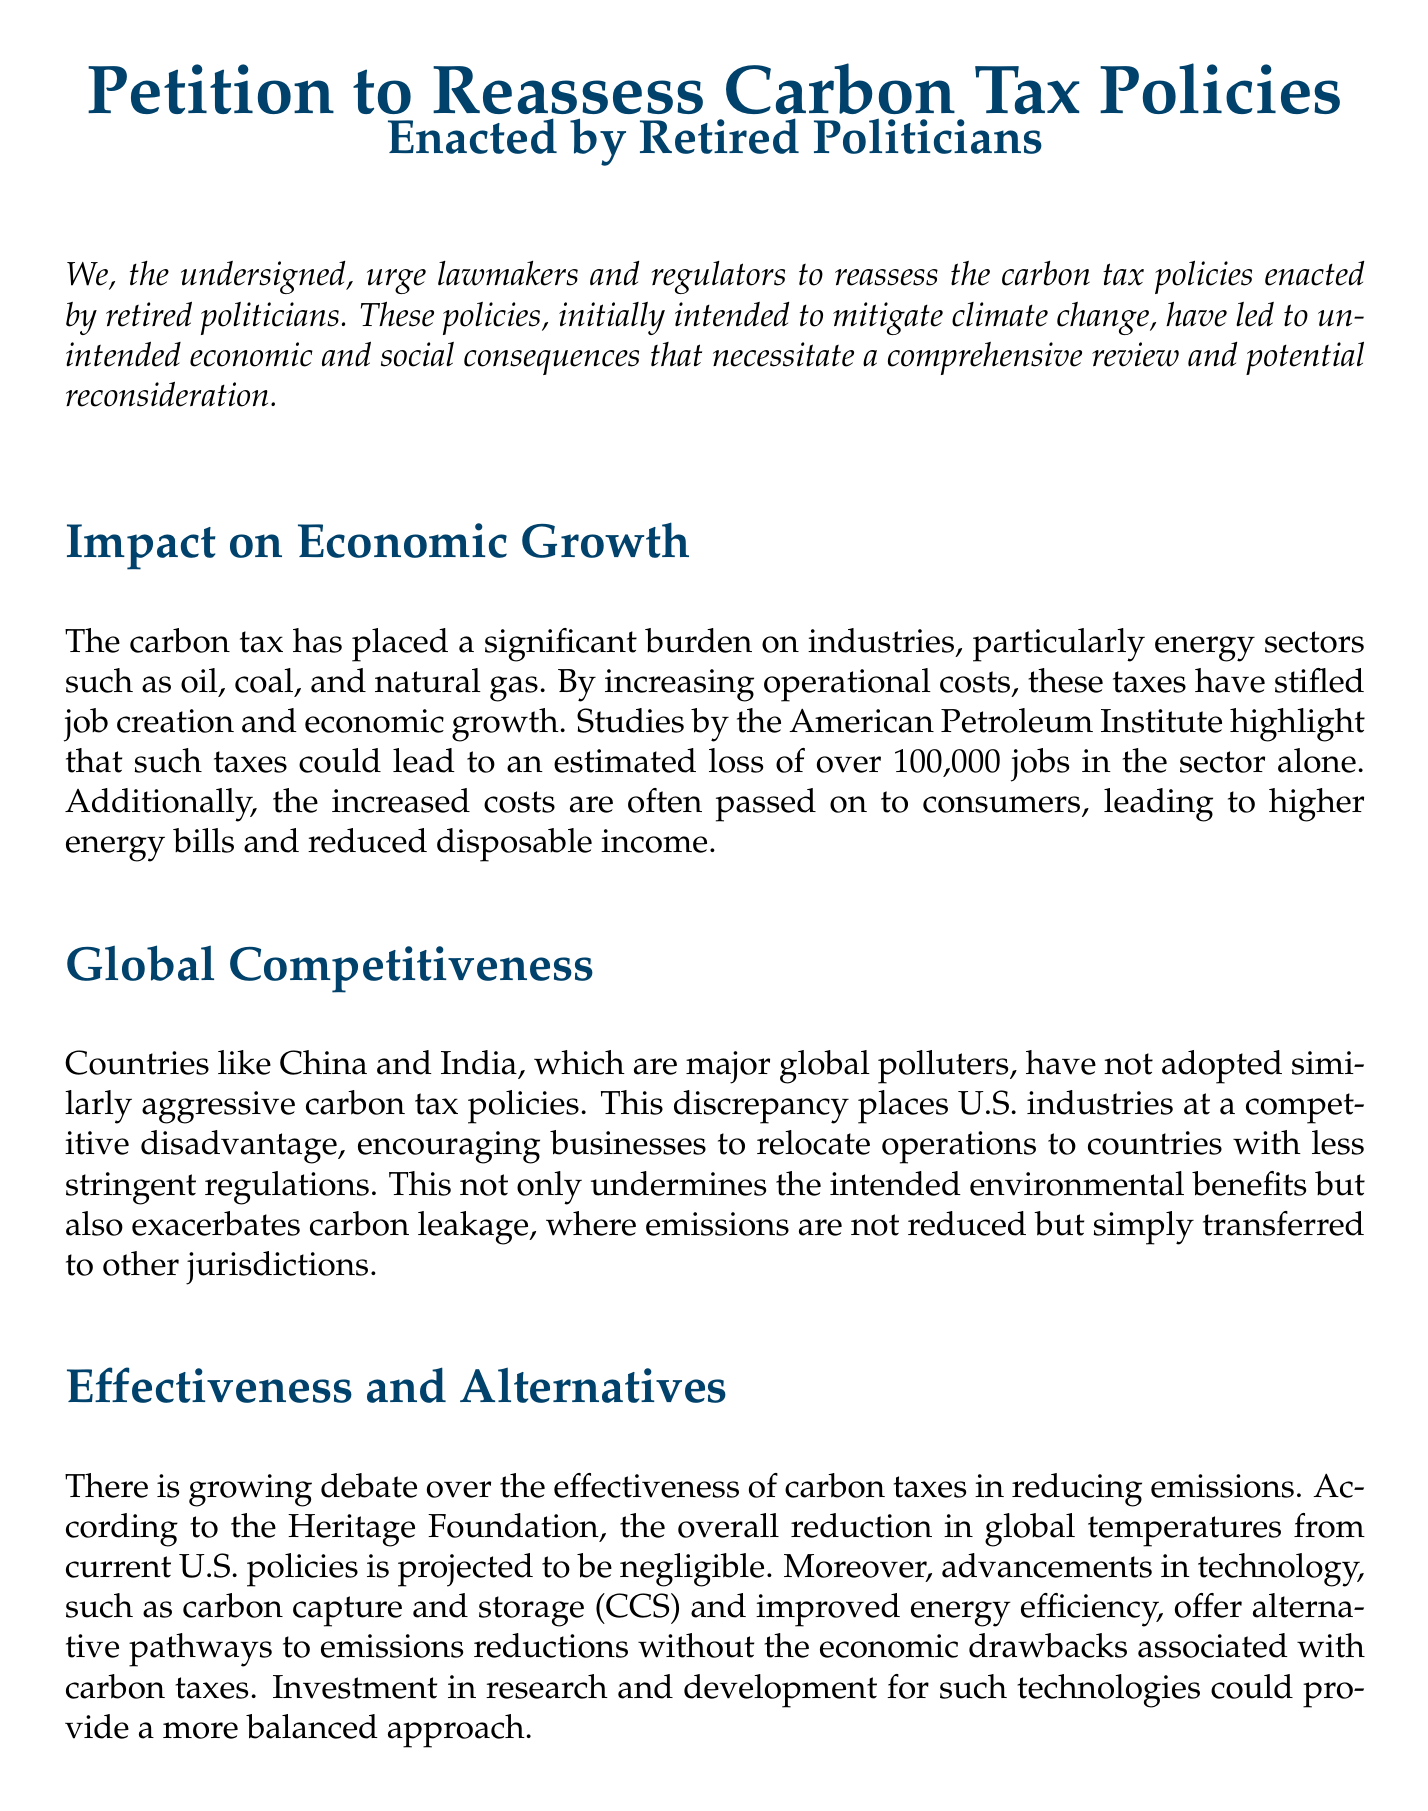What is the purpose of the petition? The petition urges lawmakers and regulators to reassess the carbon tax policies due to unintended consequences.
Answer: Reassess carbon tax policies What industries are specifically mentioned as being burdened by the carbon tax? The document highlights energy sectors such as oil, coal, and natural gas.
Answer: Oil, coal, natural gas How many jobs could be lost in the energy sector due to the carbon tax? According to studies by the American Petroleum Institute mentioned in the document, the estimated job loss is over 100,000.
Answer: Over 100,000 Which countries are noted as major global polluters that do not have similar carbon tax policies? The document specifically mentions China and India as examples.
Answer: China and India What political event in France was influenced by public opposition to fuel taxes? The document refers to the 'Yellow Vest' protests as a relevant example.
Answer: 'Yellow Vest' protests What type of committee does the petition propose to explore carbon tax impacts? The petition suggests the formation of a bipartisan committee for this purpose.
Answer: Bipartisan committee What is indicated as a potential alternative to carbon taxes for emissions reduction? The document mentions advancements in carbon capture and storage (CCS) as an alternative pathway.
Answer: Carbon capture and storage (CCS) What is the proposed action requested in the call to action section? The petition requests a thorough review of existing carbon tax policies.
Answer: Thorough review What color is used for the main title in the petition? The document indicates that petrol blue is the color used for the title.
Answer: Petrol blue What socioeconomic group is mentioned in relation to the potential harm from carbon taxes? The document references lower-income populations as being adversely affected.
Answer: Lower-income populations 